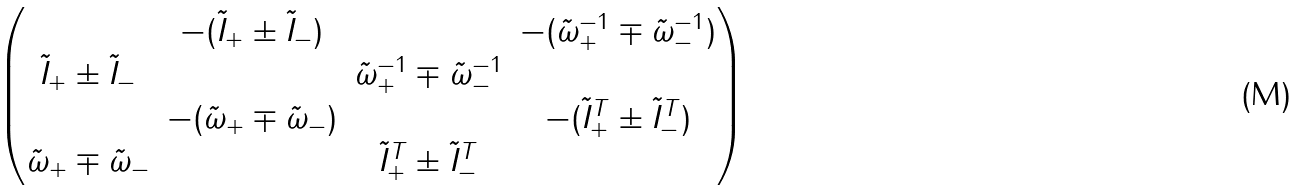Convert formula to latex. <formula><loc_0><loc_0><loc_500><loc_500>\begin{pmatrix} & - ( \tilde { I } _ { + } \pm \tilde { I } _ { - } ) & & - ( \tilde { \omega } _ { + } ^ { - 1 } \mp \tilde { \omega } _ { - } ^ { - 1 } ) \\ \tilde { I } _ { + } \pm \tilde { I } _ { - } & & \tilde { \omega } _ { + } ^ { - 1 } \mp \tilde { \omega } _ { - } ^ { - 1 } & \\ & - ( \tilde { \omega } _ { + } \mp \tilde { \omega } _ { - } ) & & - ( \tilde { I } _ { + } ^ { T } \pm \tilde { I } _ { - } ^ { T } ) \\ \tilde { \omega } _ { + } \mp \tilde { \omega } _ { - } & & \tilde { I } _ { + } ^ { T } \pm \tilde { I } _ { - } ^ { T } & \end{pmatrix}</formula> 